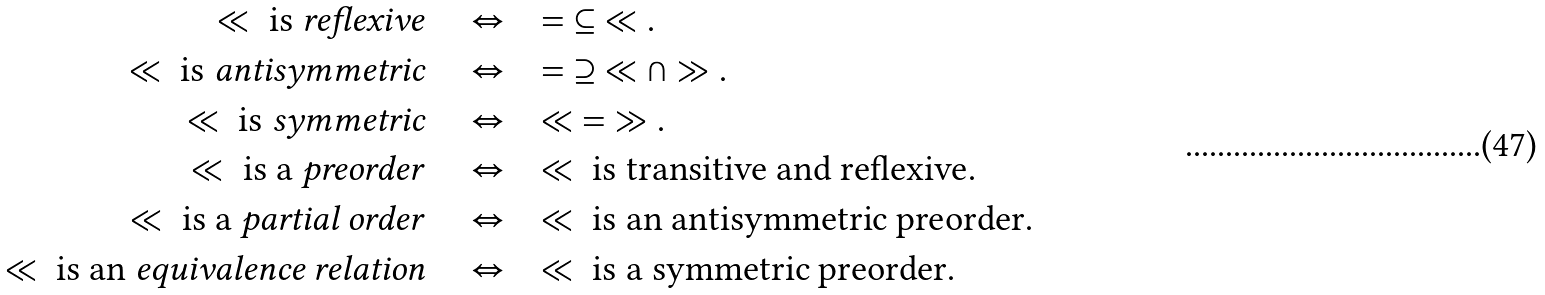Convert formula to latex. <formula><loc_0><loc_0><loc_500><loc_500>\ll \text { is \emph{reflexive}} \quad & \Leftrightarrow \quad = \ \subseteq \ \ll . \\ \ll \text { is \emph{antisymmetric}} \quad & \Leftrightarrow \quad = \ \supseteq \ \ll \cap \gg . \\ \ll \text { is \emph{symmetric}} \quad & \Leftrightarrow \quad \ll \ = \ \gg . \\ \ll \text { is a \emph{preorder}} \quad & \Leftrightarrow \quad \ll \text { is transitive and reflexive} . \\ \ll \text { is a \emph{partial order}} \quad & \Leftrightarrow \quad \ll \text { is an antisymmetric preorder} . \\ \ll \text { is an \emph{equivalence relation}} \quad & \Leftrightarrow \quad \ll \text { is a symmetric preorder} .</formula> 